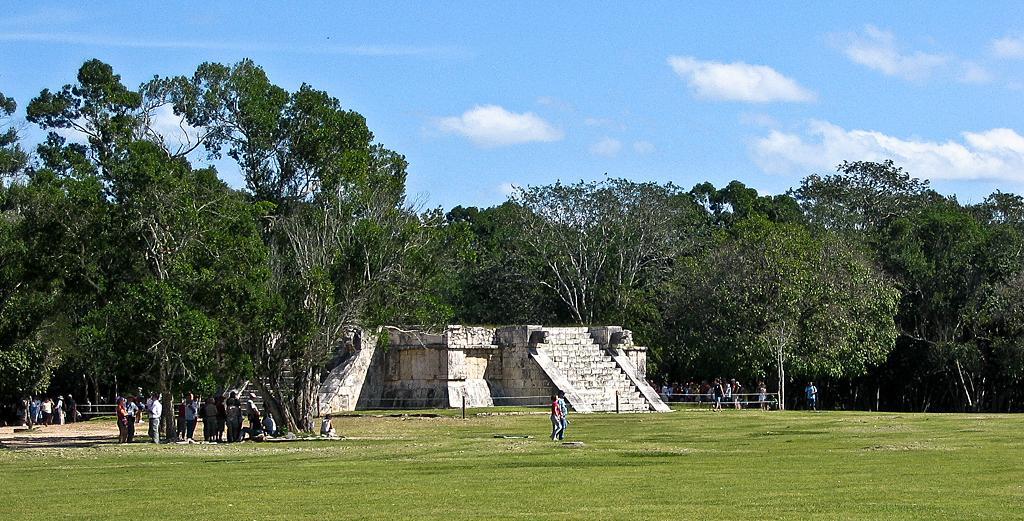Can you describe this image briefly? In this picture we can see the grass and a group of people, poles, walls, steps, trees and in the background we can see the sky with clouds. 